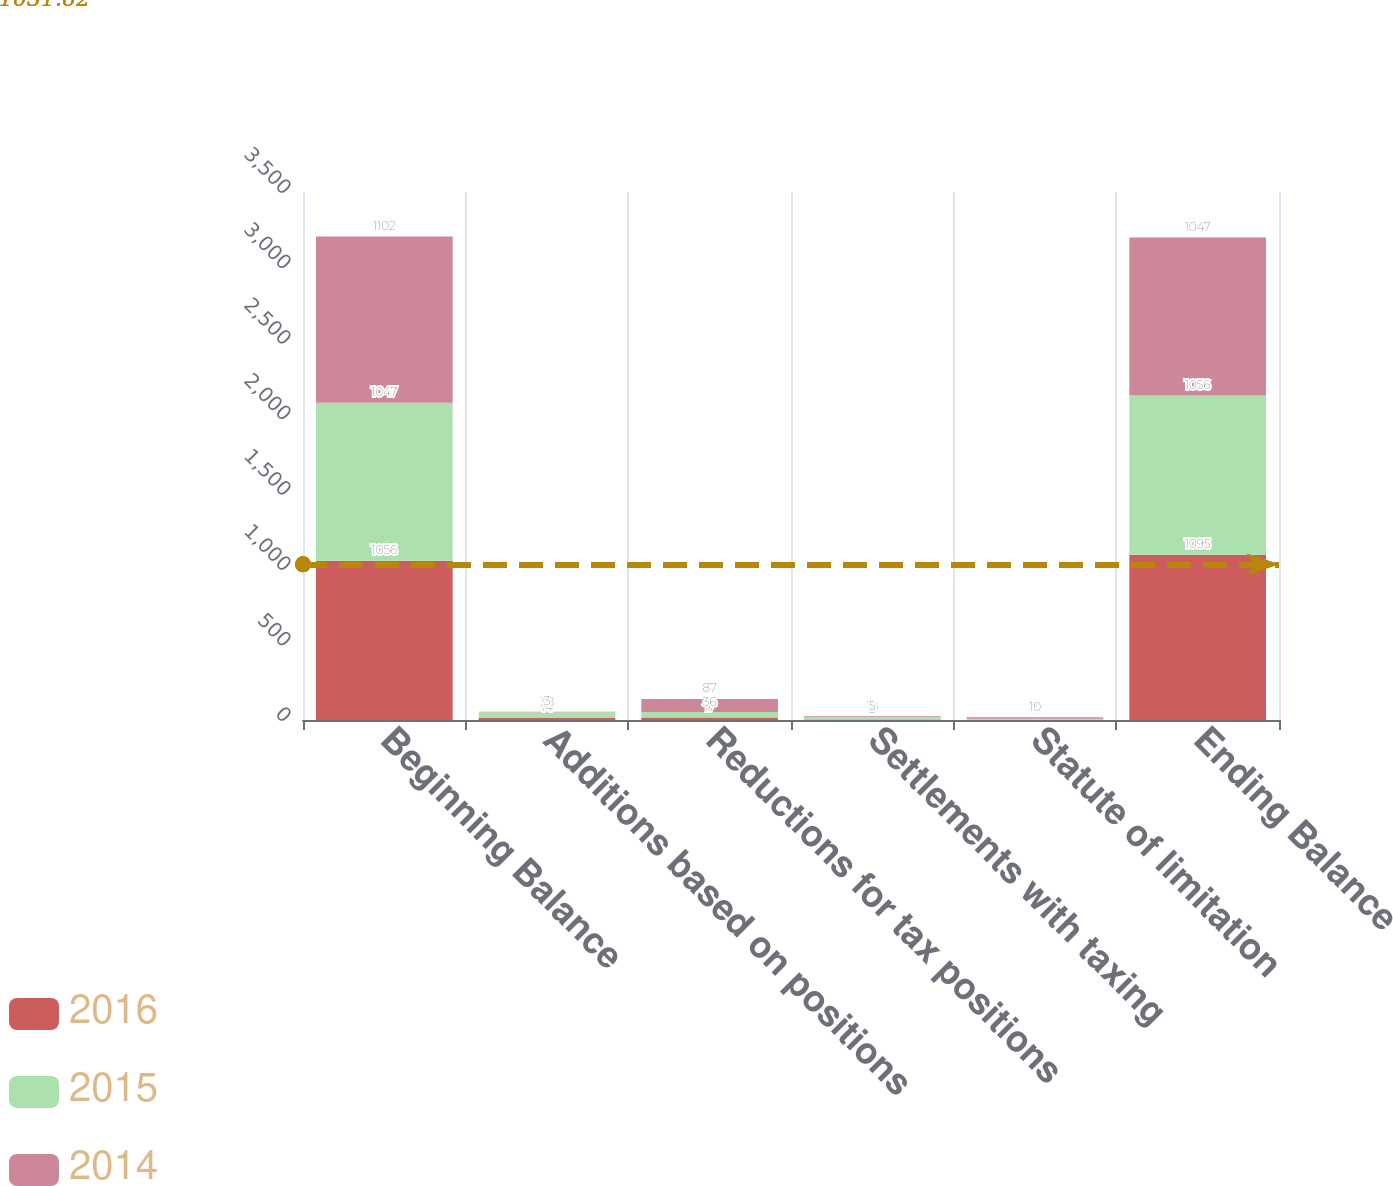Convert chart. <chart><loc_0><loc_0><loc_500><loc_500><stacked_bar_chart><ecel><fcel>Beginning Balance<fcel>Additions based on positions<fcel>Reductions for tax positions<fcel>Settlements with taxing<fcel>Statute of limitation<fcel>Ending Balance<nl><fcel>2016<fcel>1056<fcel>14<fcel>17<fcel>3<fcel>2<fcel>1095<nl><fcel>2015<fcel>1047<fcel>38<fcel>36<fcel>18<fcel>7<fcel>1056<nl><fcel>2014<fcel>1102<fcel>3<fcel>87<fcel>5<fcel>10<fcel>1047<nl></chart> 